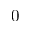Convert formula to latex. <formula><loc_0><loc_0><loc_500><loc_500>0</formula> 